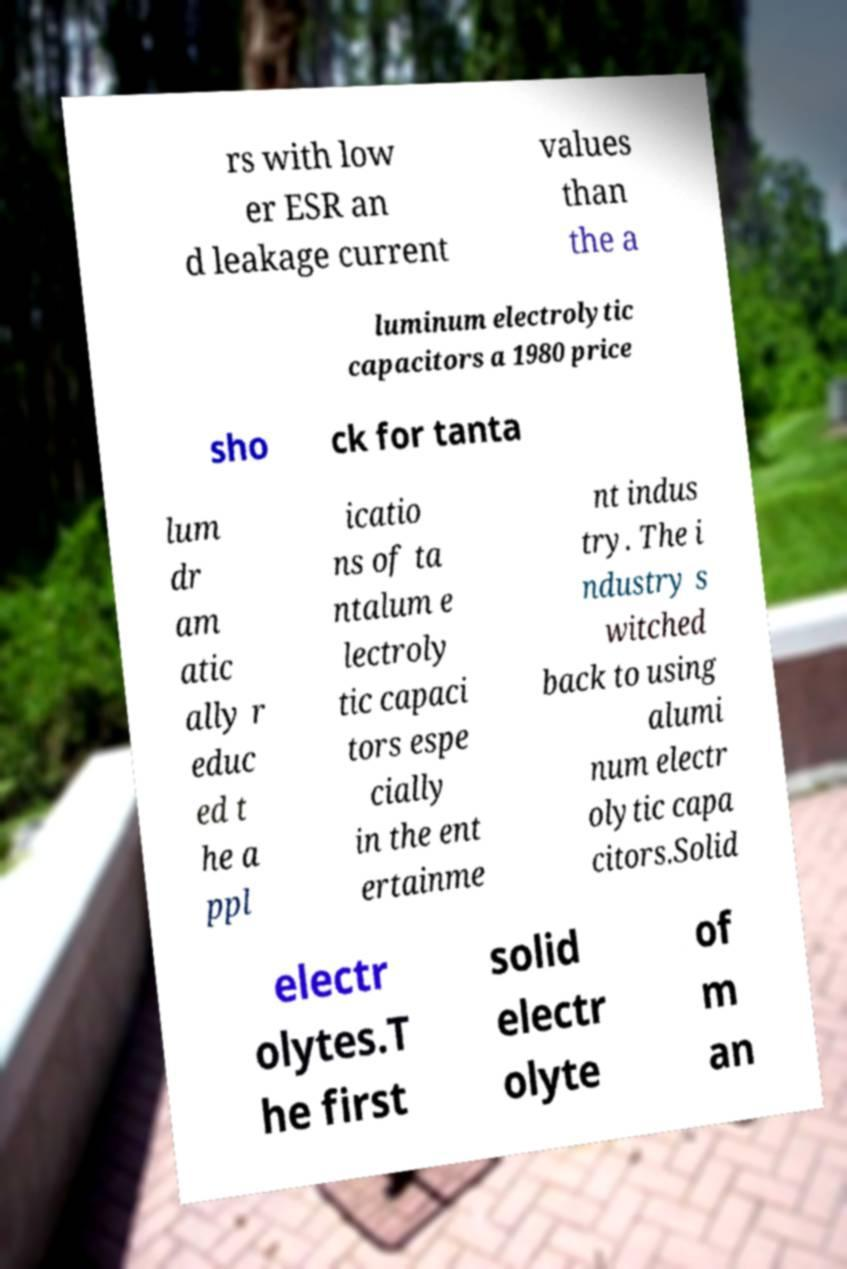There's text embedded in this image that I need extracted. Can you transcribe it verbatim? rs with low er ESR an d leakage current values than the a luminum electrolytic capacitors a 1980 price sho ck for tanta lum dr am atic ally r educ ed t he a ppl icatio ns of ta ntalum e lectroly tic capaci tors espe cially in the ent ertainme nt indus try. The i ndustry s witched back to using alumi num electr olytic capa citors.Solid electr olytes.T he first solid electr olyte of m an 